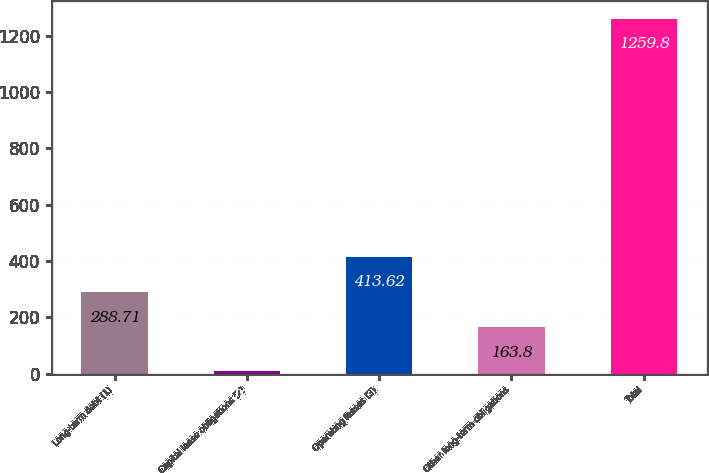Convert chart to OTSL. <chart><loc_0><loc_0><loc_500><loc_500><bar_chart><fcel>Long-term debt (1)<fcel>Capital lease obligations (2)<fcel>Operating leases (3)<fcel>Other long-term obligations<fcel>Total<nl><fcel>288.71<fcel>10.7<fcel>413.62<fcel>163.8<fcel>1259.8<nl></chart> 